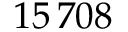Convert formula to latex. <formula><loc_0><loc_0><loc_500><loc_500>1 5 \, 7 0 8</formula> 